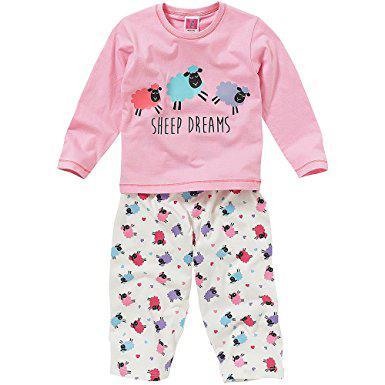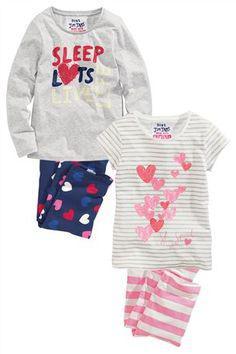The first image is the image on the left, the second image is the image on the right. Assess this claim about the two images: "At least 1 child is wearing blue patterned pajamas.". Correct or not? Answer yes or no. No. The first image is the image on the left, the second image is the image on the right. Given the left and right images, does the statement "There is more than one child in total." hold true? Answer yes or no. No. 